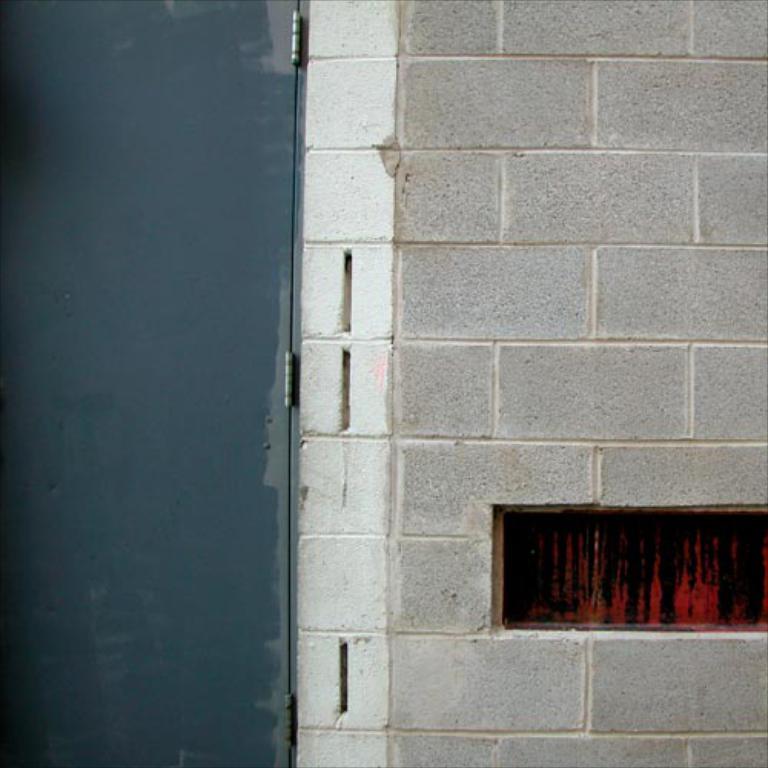Please provide a concise description of this image. In this picture we can see a brick wall and an iron door. 